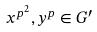Convert formula to latex. <formula><loc_0><loc_0><loc_500><loc_500>x ^ { p ^ { 2 } } , y ^ { p } \in G ^ { \prime }</formula> 